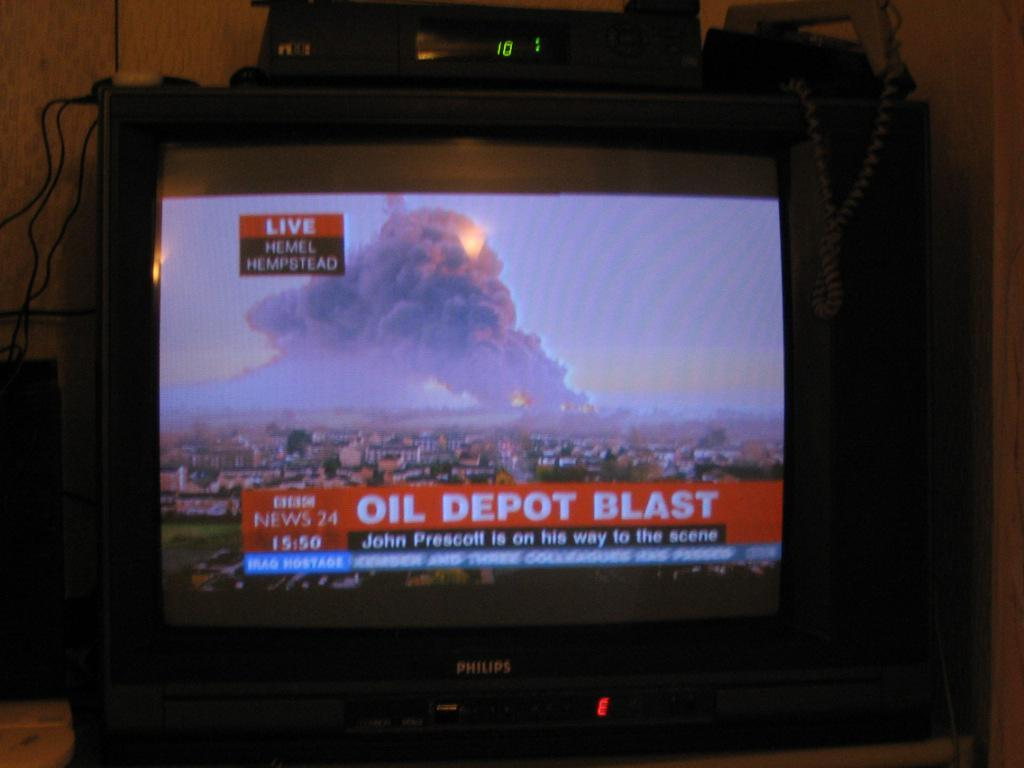<image>
Summarize the visual content of the image. An old Philips TV is showing a news report of a fire that says Oil Depot Blast. 